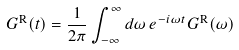Convert formula to latex. <formula><loc_0><loc_0><loc_500><loc_500>G ^ { \text {R} } ( t ) = \frac { 1 } { 2 \pi } \int _ { - \infty } ^ { \infty } d \omega \, e ^ { - i \omega t } G ^ { \text {R} } ( \omega )</formula> 